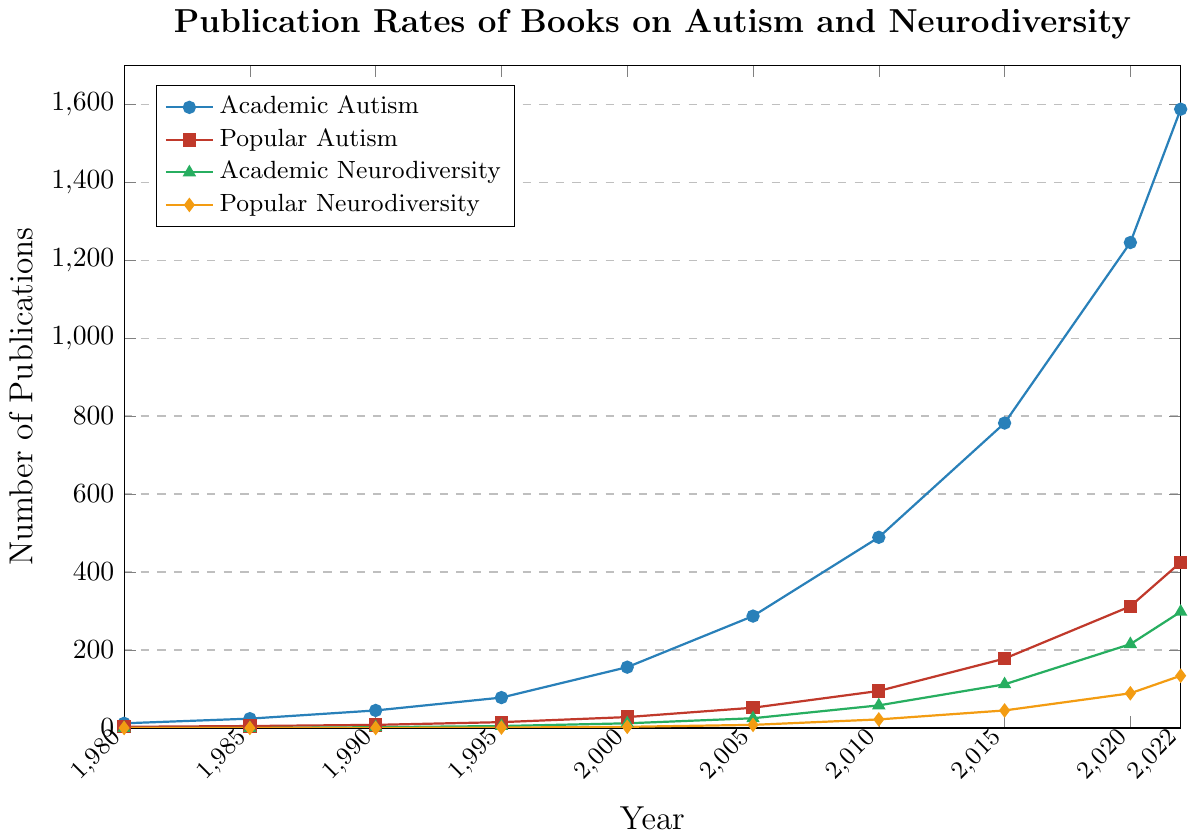What was the number of academic autism publications in the year 2000? Locate the point on the "Academic Autism" line corresponding to the year 2000, which is marked in dark blue. Notice that this point lies at the y-value of 156.
Answer: 156 Which category saw the highest increase in the number of publications between 1980 and 2022? To determine the category with the highest increase, calculate the difference between the 2022 and 1980 values for each category. Academic Autism increases from 12 to 1587, Popular Autism from 3 to 425, Academic Neurodiversity from 0 to 298, and Popular Neurodiversity from 0 to 134. The highest increase is in Academic Autism (1587 - 12 = 1575).
Answer: Academic Autism Compare the number of popular neurodiversity publications in 2010 and 2015. Which year had more publications and by how much? Check the "Popular Neurodiversity" line marked in orange at the years 2010 and 2015. In 2010, there are 22 publications, and in 2015, there are 45 publications. 2015 had more publications by 45 - 22 = 23.
Answer: 2015, by 23 In which year did academic neurodiversity publications first surpass 100? Check the "Academic Neurodiversity" line marked in green and identify the year when the y-value first exceeds 100. This occurs in 2015, where the y-value is 112.
Answer: 2015 How many total publications (sum of all categories) were there in the year 2020? Sum the y-values of all four categories in 2020. Academic Autism: 1245, Popular Autism: 312, Academic Neurodiversity: 215, Popular Neurodiversity: 89. The total publications are 1245 + 312 + 215 + 89 = 1861.
Answer: 1861 